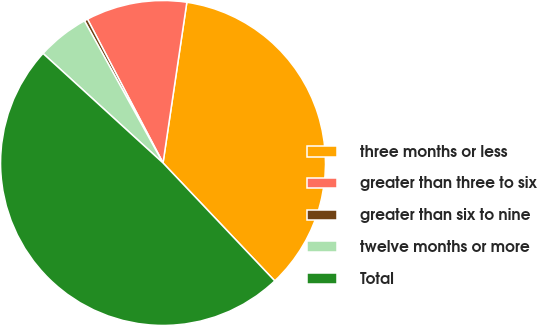<chart> <loc_0><loc_0><loc_500><loc_500><pie_chart><fcel>three months or less<fcel>greater than three to six<fcel>greater than six to nine<fcel>twelve months or more<fcel>Total<nl><fcel>35.59%<fcel>10.04%<fcel>0.34%<fcel>5.19%<fcel>48.85%<nl></chart> 